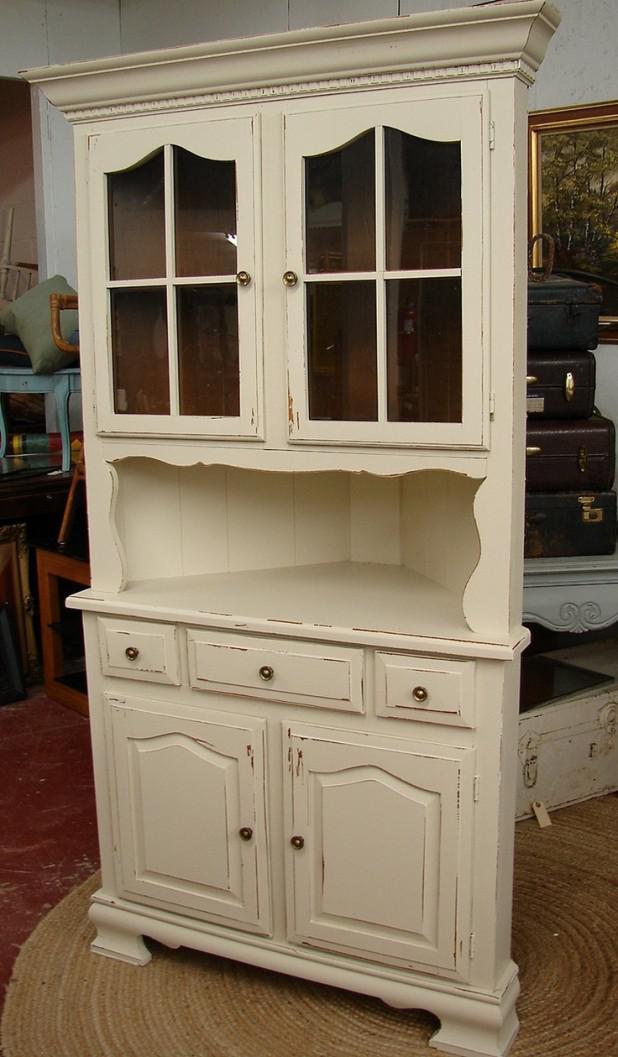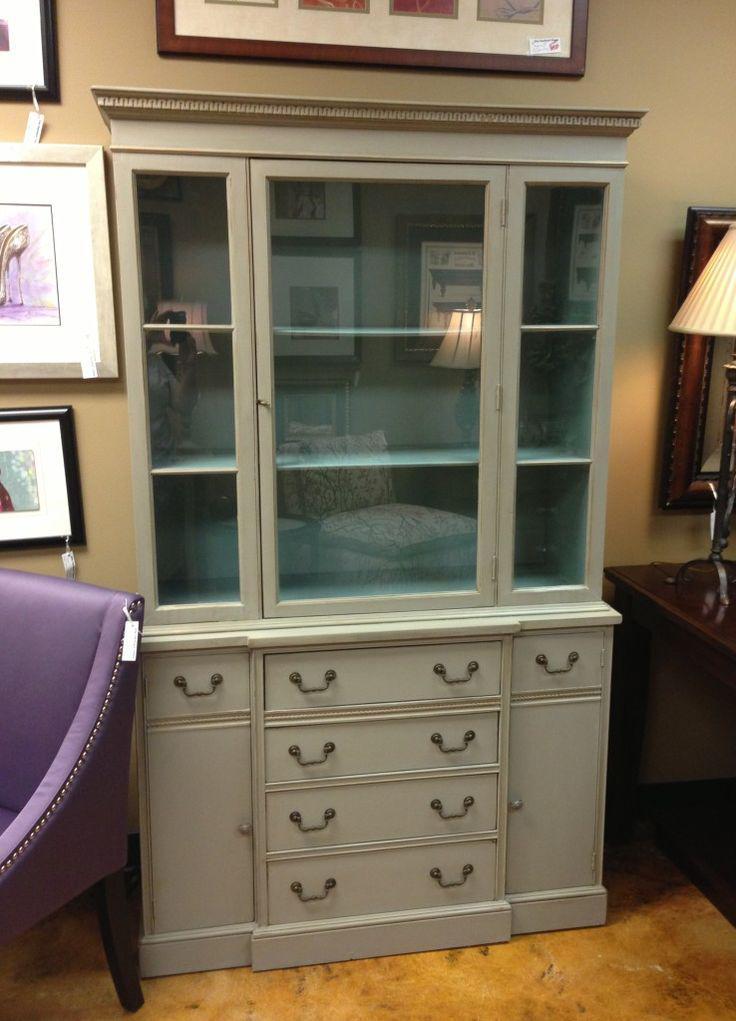The first image is the image on the left, the second image is the image on the right. For the images displayed, is the sentence "One cabinet has an open space with scrolled edges under the glass-front cabinets." factually correct? Answer yes or no. Yes. The first image is the image on the left, the second image is the image on the right. Analyze the images presented: Is the assertion "The inside of one of the cabinets is an aqua color." valid? Answer yes or no. Yes. 